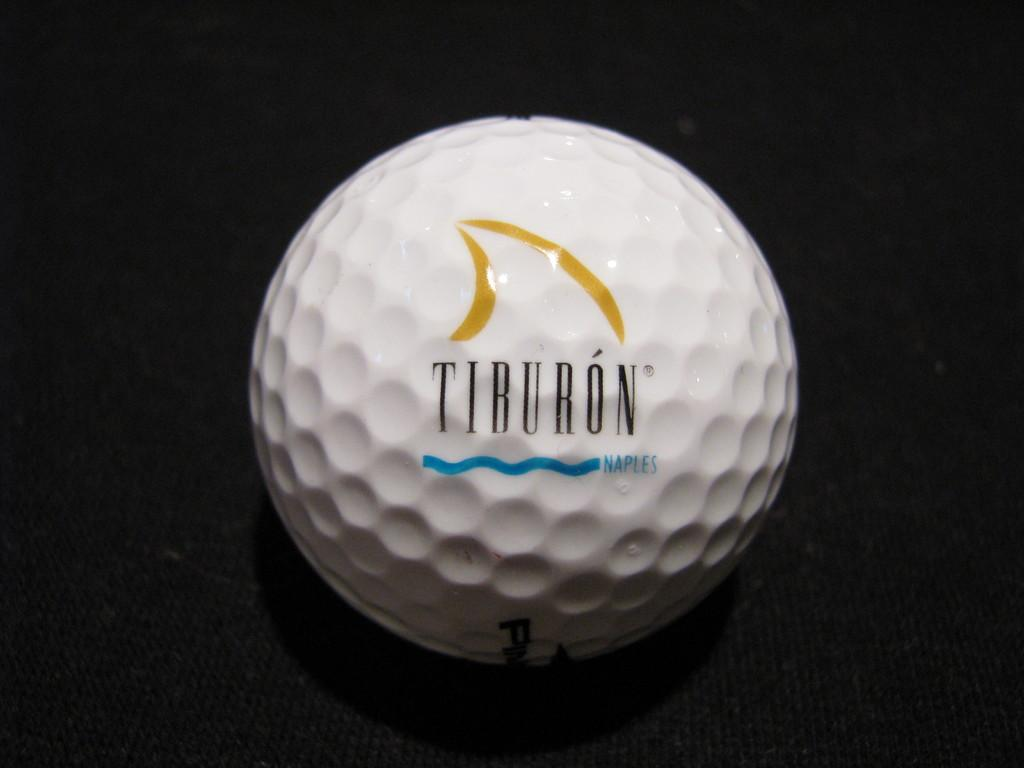<image>
Render a clear and concise summary of the photo. A golf ball with the word Tiburon on it 